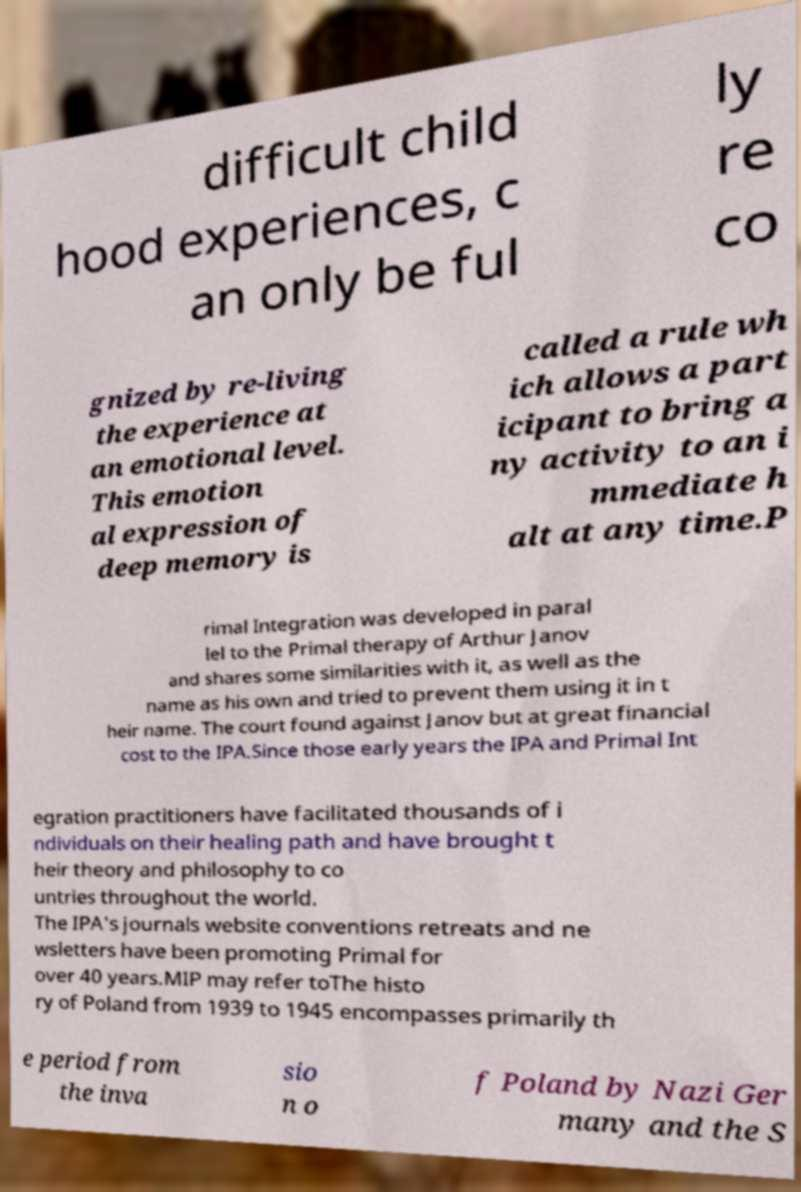There's text embedded in this image that I need extracted. Can you transcribe it verbatim? difficult child hood experiences, c an only be ful ly re co gnized by re-living the experience at an emotional level. This emotion al expression of deep memory is called a rule wh ich allows a part icipant to bring a ny activity to an i mmediate h alt at any time.P rimal Integration was developed in paral lel to the Primal therapy of Arthur Janov and shares some similarities with it, as well as the name as his own and tried to prevent them using it in t heir name. The court found against Janov but at great financial cost to the IPA.Since those early years the IPA and Primal Int egration practitioners have facilitated thousands of i ndividuals on their healing path and have brought t heir theory and philosophy to co untries throughout the world. The IPA's journals website conventions retreats and ne wsletters have been promoting Primal for over 40 years.MIP may refer toThe histo ry of Poland from 1939 to 1945 encompasses primarily th e period from the inva sio n o f Poland by Nazi Ger many and the S 